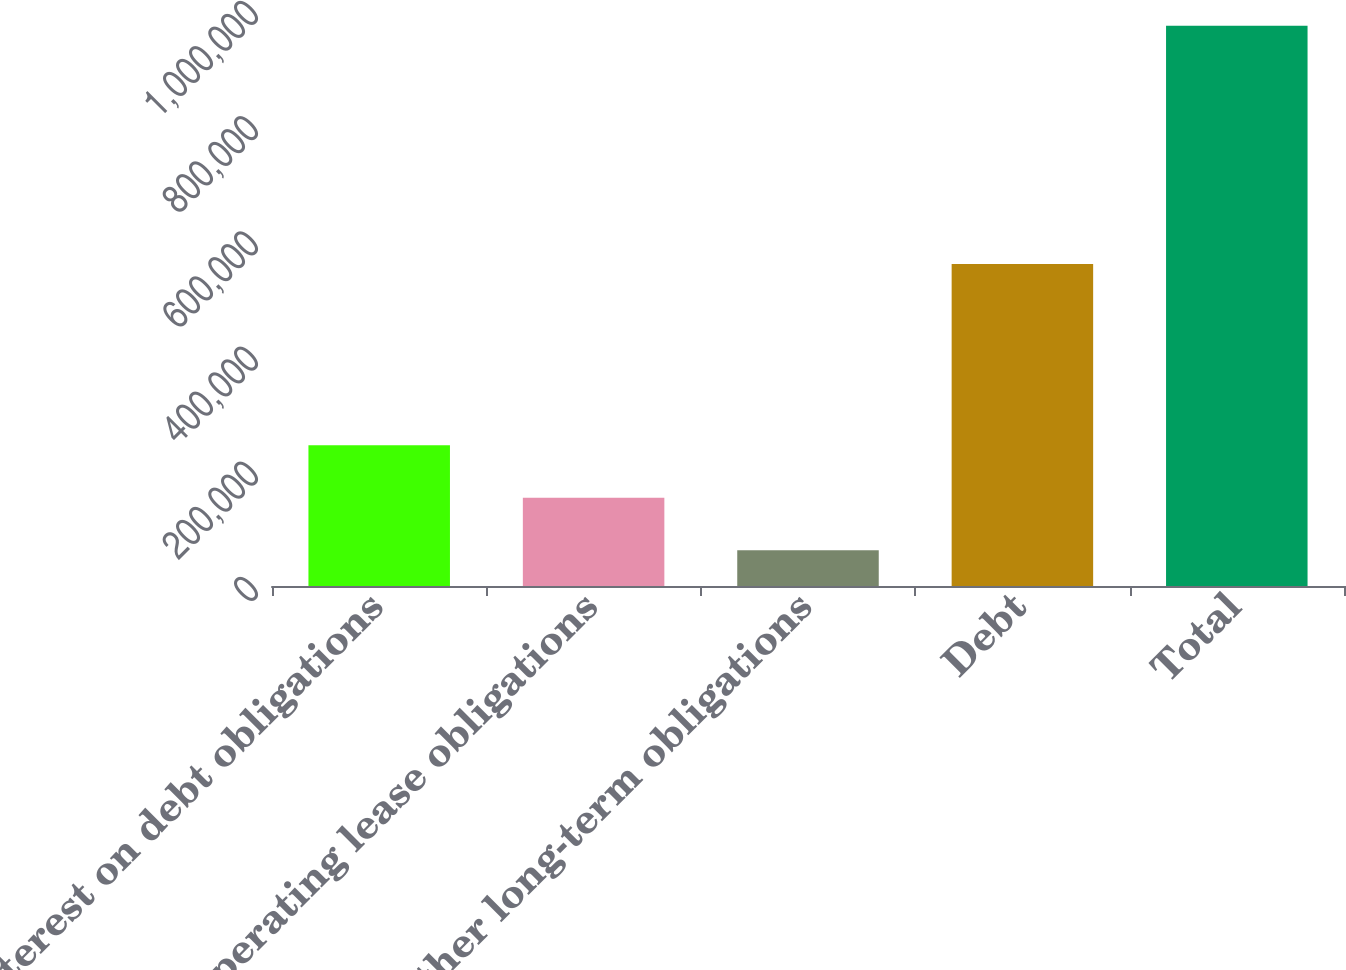Convert chart. <chart><loc_0><loc_0><loc_500><loc_500><bar_chart><fcel>Interest on debt obligations<fcel>Operating lease obligations<fcel>Other long-term obligations<fcel>Debt<fcel>Total<nl><fcel>244237<fcel>153176<fcel>62115<fcel>558857<fcel>972727<nl></chart> 